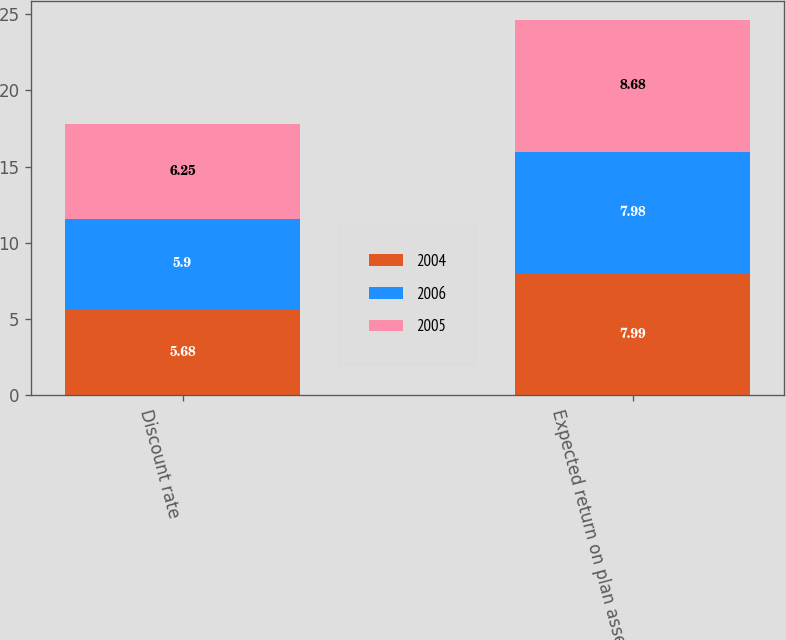Convert chart. <chart><loc_0><loc_0><loc_500><loc_500><stacked_bar_chart><ecel><fcel>Discount rate<fcel>Expected return on plan assets<nl><fcel>2004<fcel>5.68<fcel>7.99<nl><fcel>2006<fcel>5.9<fcel>7.98<nl><fcel>2005<fcel>6.25<fcel>8.68<nl></chart> 